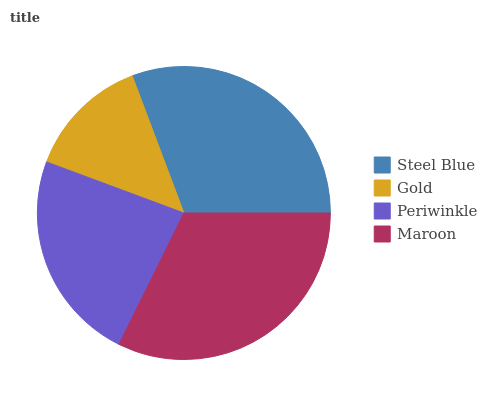Is Gold the minimum?
Answer yes or no. Yes. Is Maroon the maximum?
Answer yes or no. Yes. Is Periwinkle the minimum?
Answer yes or no. No. Is Periwinkle the maximum?
Answer yes or no. No. Is Periwinkle greater than Gold?
Answer yes or no. Yes. Is Gold less than Periwinkle?
Answer yes or no. Yes. Is Gold greater than Periwinkle?
Answer yes or no. No. Is Periwinkle less than Gold?
Answer yes or no. No. Is Steel Blue the high median?
Answer yes or no. Yes. Is Periwinkle the low median?
Answer yes or no. Yes. Is Periwinkle the high median?
Answer yes or no. No. Is Steel Blue the low median?
Answer yes or no. No. 